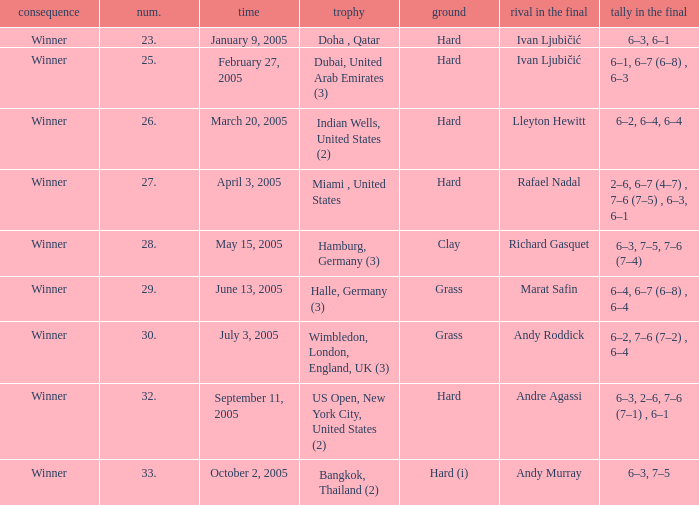Can you give me this table as a dict? {'header': ['consequence', 'num.', 'time', 'trophy', 'ground', 'rival in the final', 'tally in the final'], 'rows': [['Winner', '23.', 'January 9, 2005', 'Doha , Qatar', 'Hard', 'Ivan Ljubičić', '6–3, 6–1'], ['Winner', '25.', 'February 27, 2005', 'Dubai, United Arab Emirates (3)', 'Hard', 'Ivan Ljubičić', '6–1, 6–7 (6–8) , 6–3'], ['Winner', '26.', 'March 20, 2005', 'Indian Wells, United States (2)', 'Hard', 'Lleyton Hewitt', '6–2, 6–4, 6–4'], ['Winner', '27.', 'April 3, 2005', 'Miami , United States', 'Hard', 'Rafael Nadal', '2–6, 6–7 (4–7) , 7–6 (7–5) , 6–3, 6–1'], ['Winner', '28.', 'May 15, 2005', 'Hamburg, Germany (3)', 'Clay', 'Richard Gasquet', '6–3, 7–5, 7–6 (7–4)'], ['Winner', '29.', 'June 13, 2005', 'Halle, Germany (3)', 'Grass', 'Marat Safin', '6–4, 6–7 (6–8) , 6–4'], ['Winner', '30.', 'July 3, 2005', 'Wimbledon, London, England, UK (3)', 'Grass', 'Andy Roddick', '6–2, 7–6 (7–2) , 6–4'], ['Winner', '32.', 'September 11, 2005', 'US Open, New York City, United States (2)', 'Hard', 'Andre Agassi', '6–3, 2–6, 7–6 (7–1) , 6–1'], ['Winner', '33.', 'October 2, 2005', 'Bangkok, Thailand (2)', 'Hard (i)', 'Andy Murray', '6–3, 7–5']]} In the championship Indian Wells, United States (2), who are the opponents in the final? Lleyton Hewitt. 